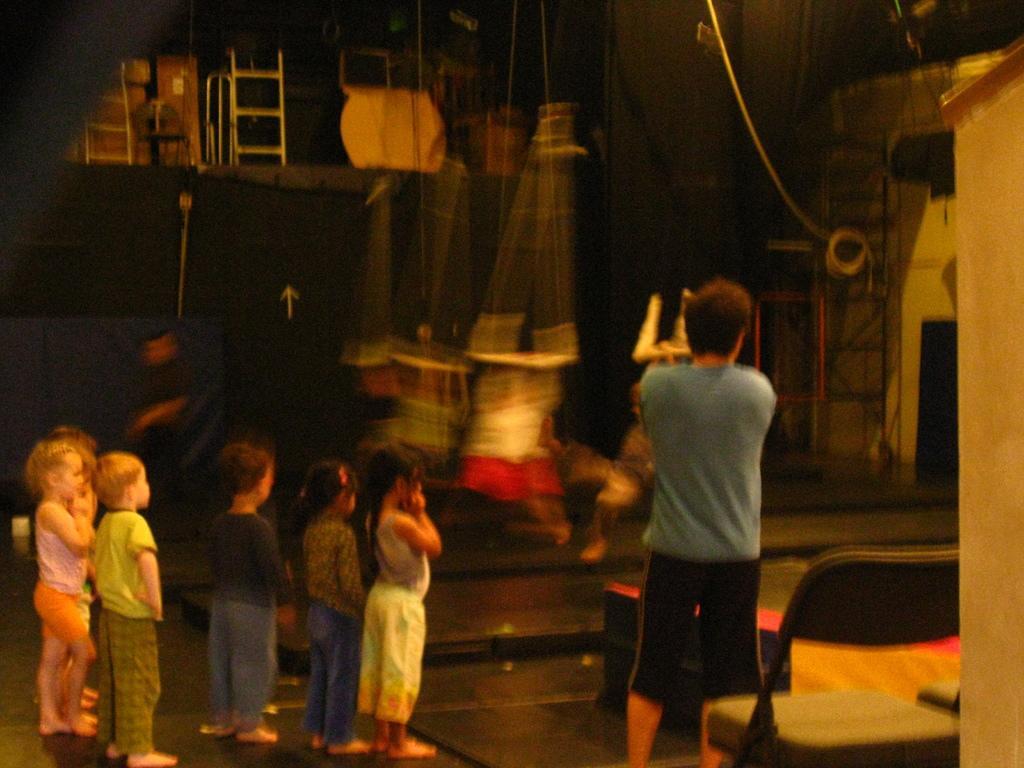Can you describe this image briefly? In this picture we can see a man and a group of children's standing on the floor, chair, ladders and in the background we can see some objects. 